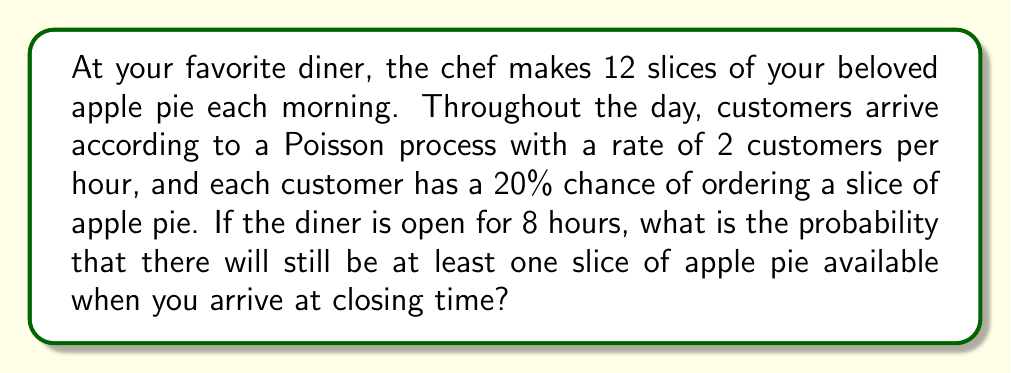Solve this math problem. Let's approach this step-by-step:

1) First, we need to find the distribution of the number of apple pie slices sold during the day.

2) The number of customers arriving follows a Poisson distribution with rate $\lambda = 2 * 8 = 16$ (2 customers per hour for 8 hours).

3) Each customer has a 20% chance of ordering a slice. This means that each customer's order can be modeled as a Bernoulli trial with $p = 0.2$.

4) The combination of a Poisson process for arrivals and Bernoulli trials for each customer results in a Poisson distribution for the number of slices sold. The rate of this new Poisson distribution is:

   $\lambda_{new} = \lambda * p = 16 * 0.2 = 3.2$

5) Now, we want to find the probability that 11 or fewer slices are sold (leaving at least one slice available). This is equivalent to finding the probability that 12 or more slices are not sold.

6) Using the cumulative distribution function of the Poisson distribution:

   $P(X \leq 11) = 1 - P(X \geq 12)$

   $= 1 - \sum_{k=12}^{\infty} \frac{e^{-3.2} 3.2^k}{k!}$

7) This can be calculated using the complementary cumulative distribution function of the Poisson distribution:

   $= 1 - (1 - \sum_{k=0}^{11} \frac{e^{-3.2} 3.2^k}{k!})$

8) Using a calculator or programming language to compute this sum:

   $\approx 0.9998$

Therefore, there is approximately a 99.98% chance that at least one slice of apple pie will be available at closing time.
Answer: The probability that there will still be at least one slice of apple pie available when you arrive at closing time is approximately 0.9998 or 99.98%. 